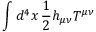<formula> <loc_0><loc_0><loc_500><loc_500>\int d ^ { 4 } x \, { \frac { 1 } { 2 } } h _ { \mu \nu } T ^ { \mu \nu }</formula> 